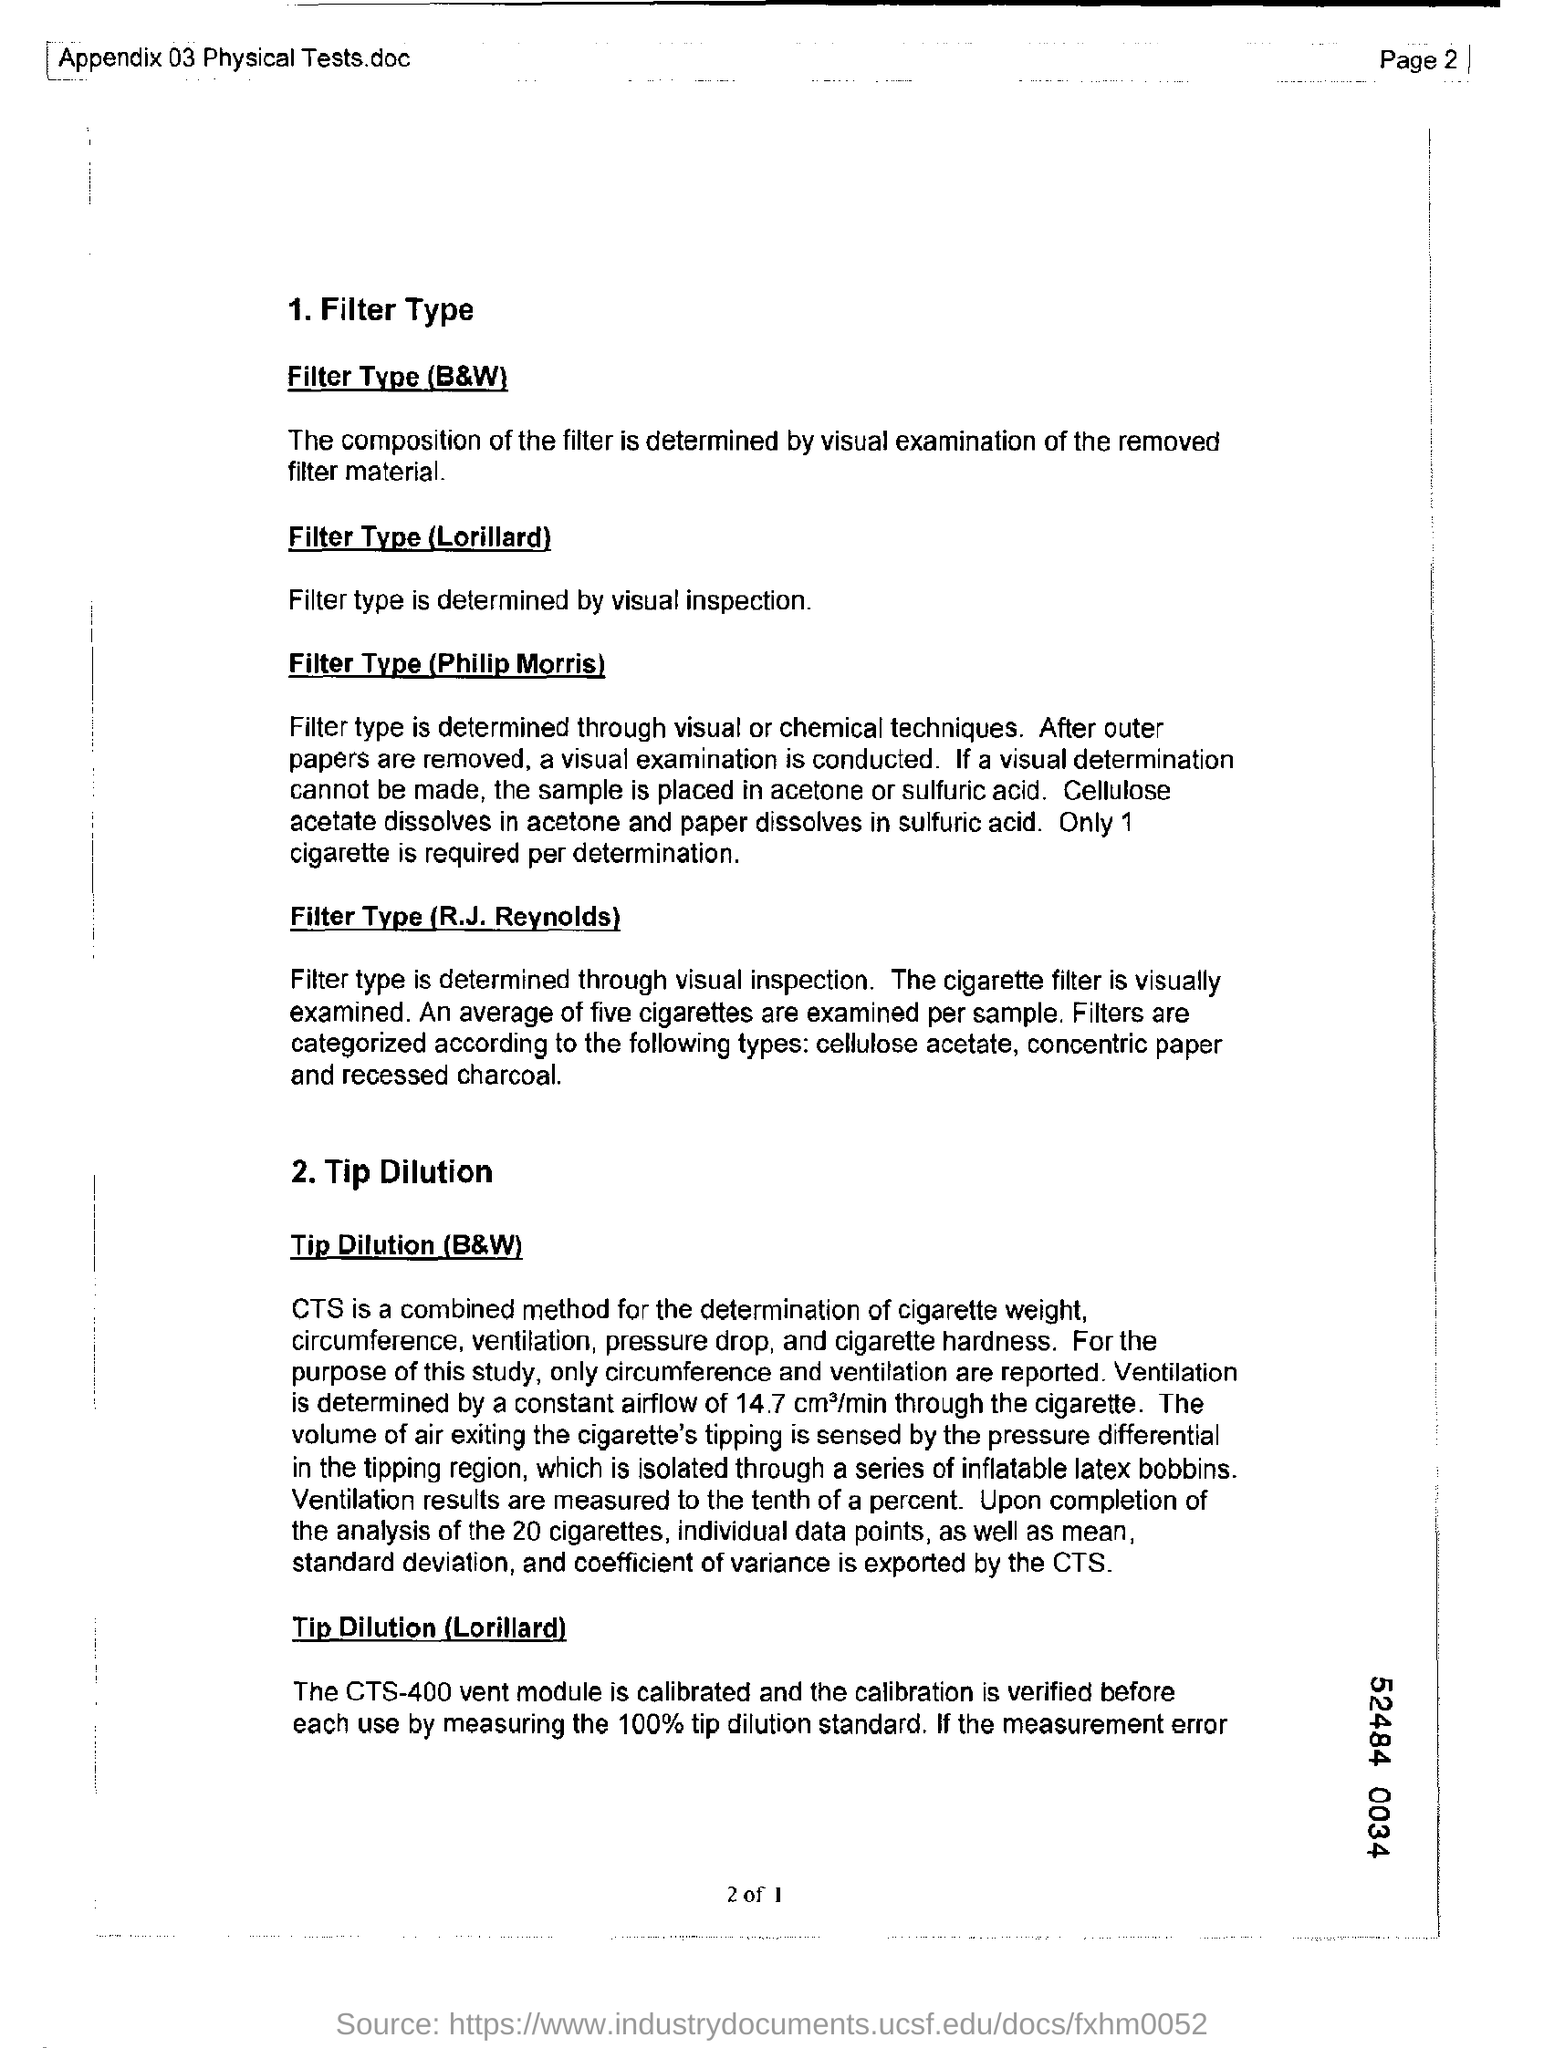List a handful of essential elements in this visual. The combined method for determining the weight of cigarettes involves the use of both the Coulter Counter and the Titration method. The filter type used in Philip Morris products is determined by a combination of visual and chemical techniques. The type of filter used in cigarettes, such as Lorillard's, is determined by visual inspection. 